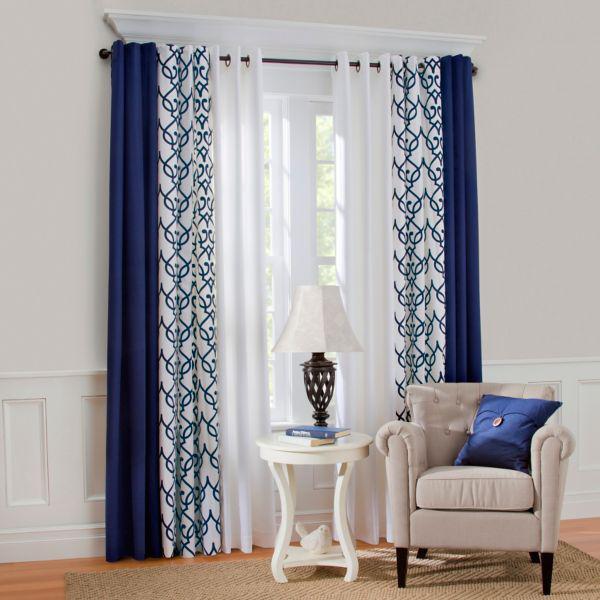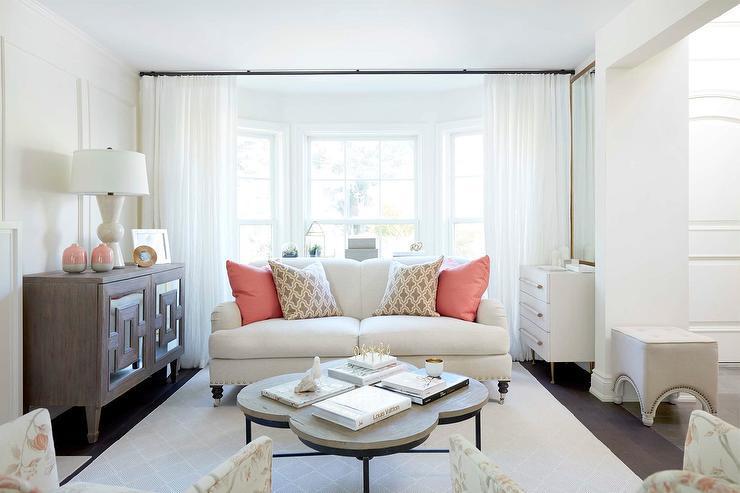The first image is the image on the left, the second image is the image on the right. Examine the images to the left and right. Is the description "Sheer white drapes hang from a black horizontal bar in a white room with seating furniture, in one image." accurate? Answer yes or no. Yes. 